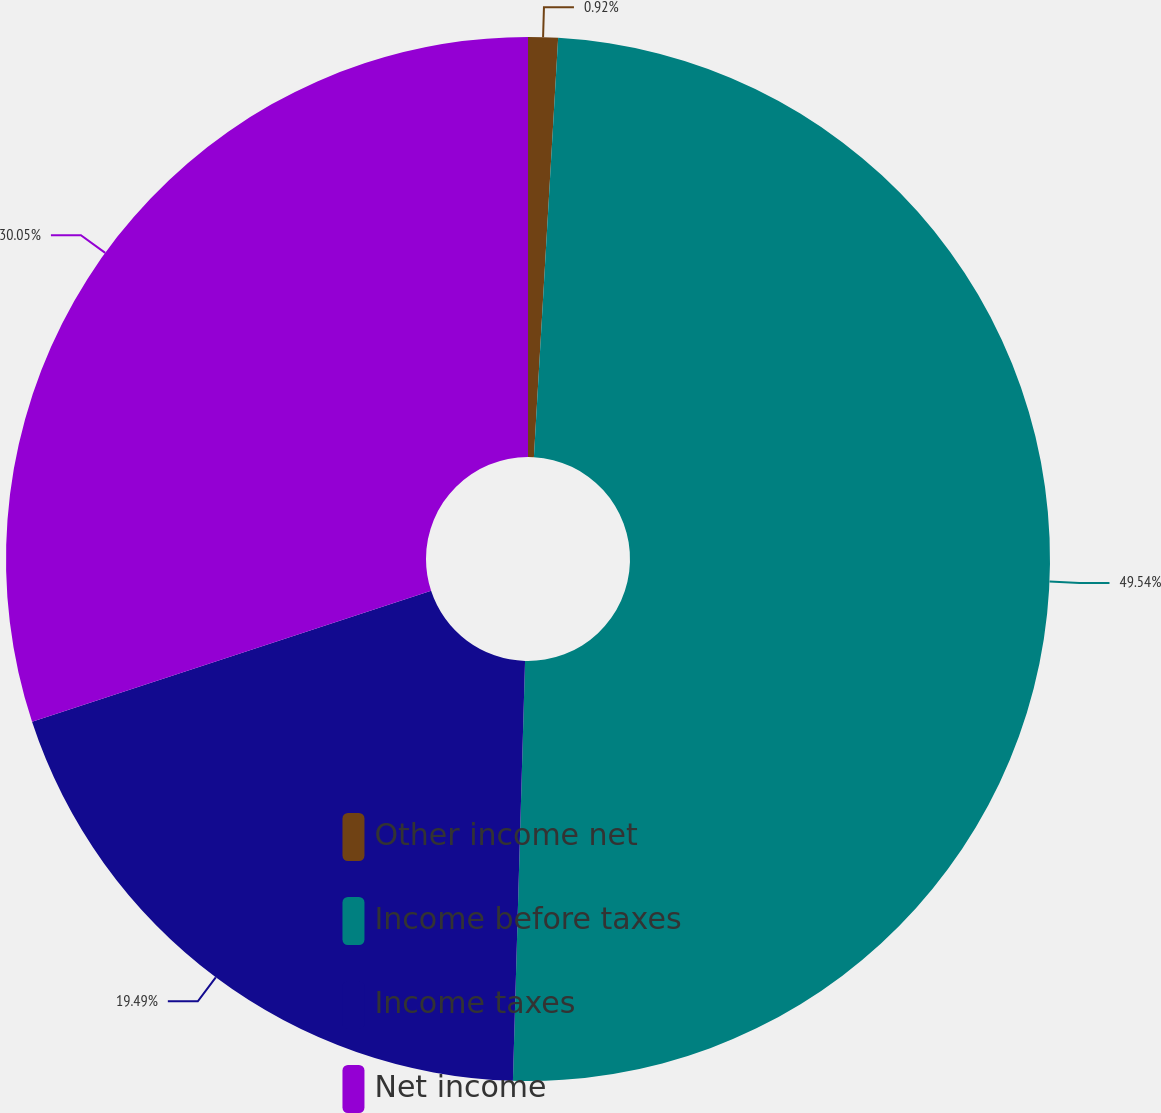Convert chart. <chart><loc_0><loc_0><loc_500><loc_500><pie_chart><fcel>Other income net<fcel>Income before taxes<fcel>Income taxes<fcel>Net income<nl><fcel>0.92%<fcel>49.54%<fcel>19.49%<fcel>30.05%<nl></chart> 